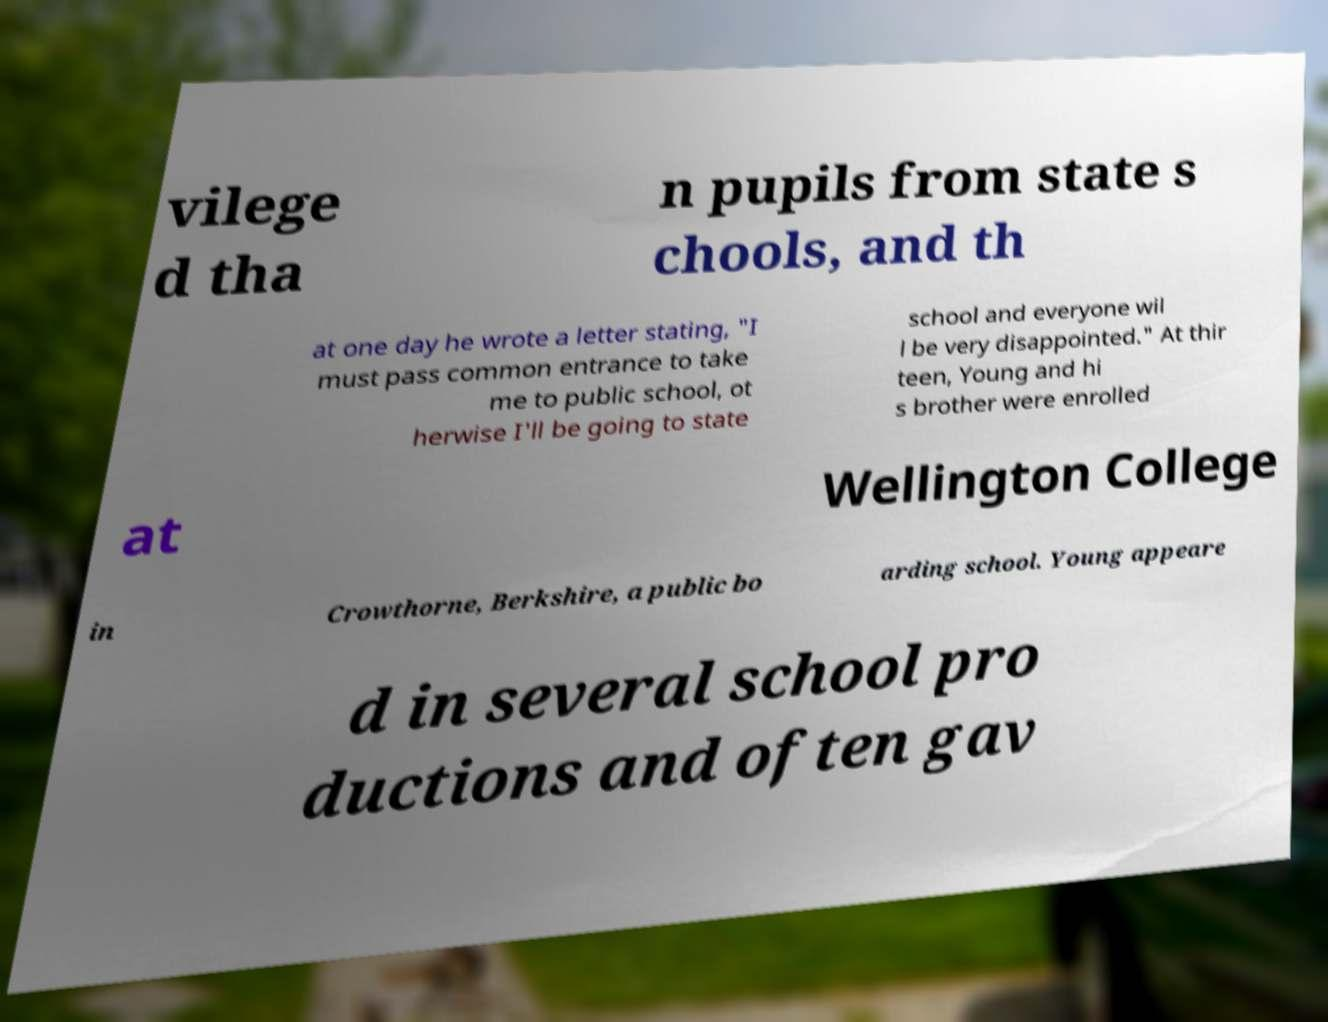Can you accurately transcribe the text from the provided image for me? vilege d tha n pupils from state s chools, and th at one day he wrote a letter stating, "I must pass common entrance to take me to public school, ot herwise I'll be going to state school and everyone wil l be very disappointed." At thir teen, Young and hi s brother were enrolled at Wellington College in Crowthorne, Berkshire, a public bo arding school. Young appeare d in several school pro ductions and often gav 